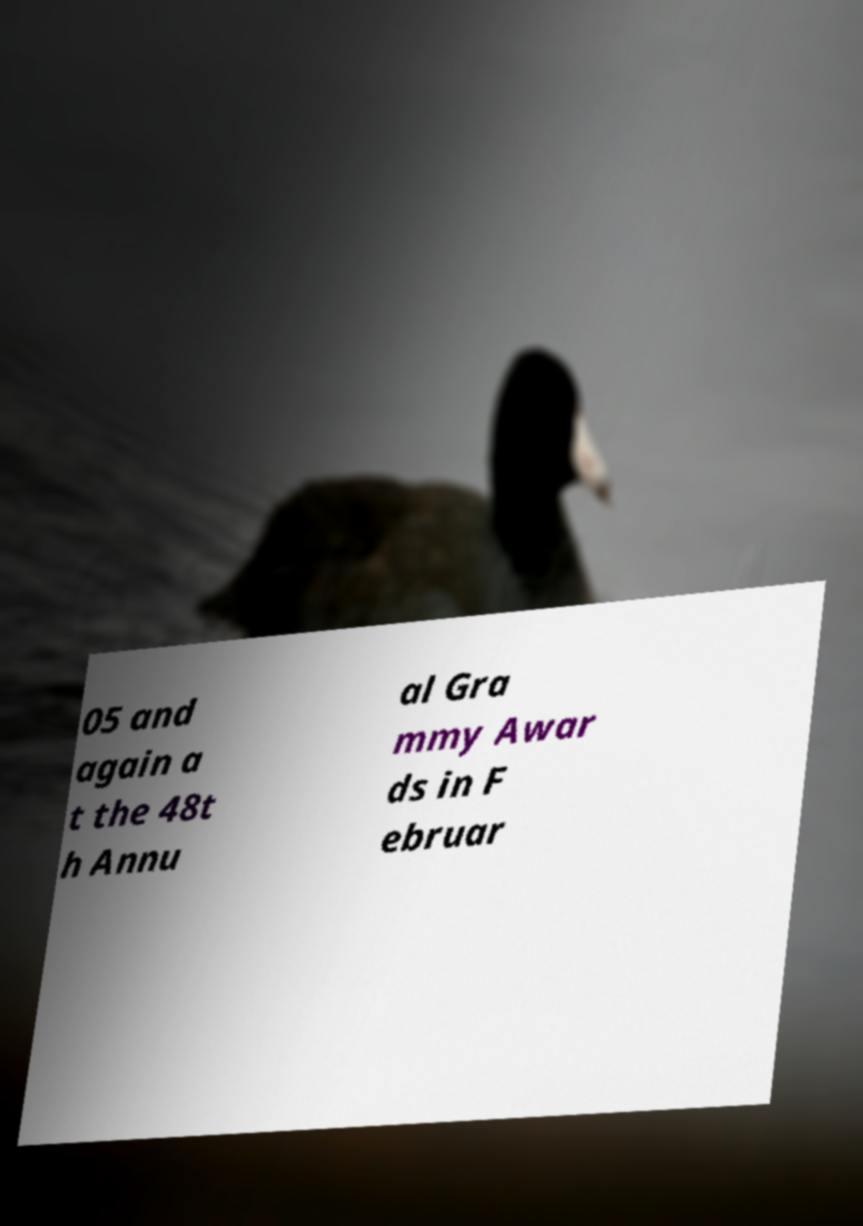Please read and relay the text visible in this image. What does it say? 05 and again a t the 48t h Annu al Gra mmy Awar ds in F ebruar 